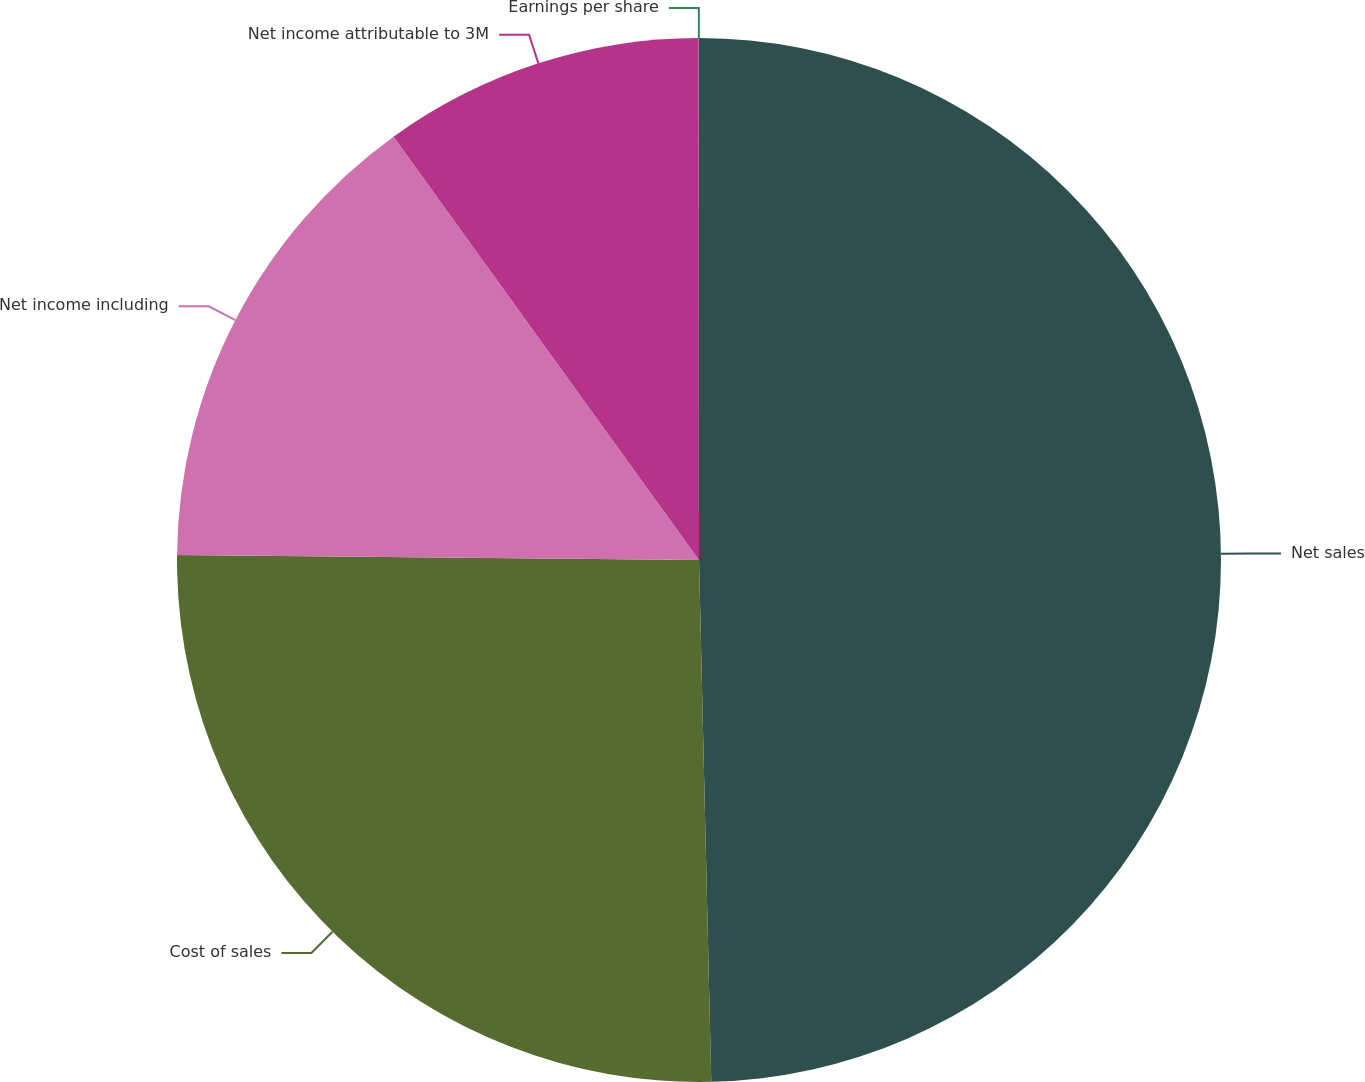Convert chart to OTSL. <chart><loc_0><loc_0><loc_500><loc_500><pie_chart><fcel>Net sales<fcel>Cost of sales<fcel>Net income including<fcel>Net income attributable to 3M<fcel>Earnings per share<nl><fcel>49.63%<fcel>25.53%<fcel>14.9%<fcel>9.94%<fcel>0.01%<nl></chart> 